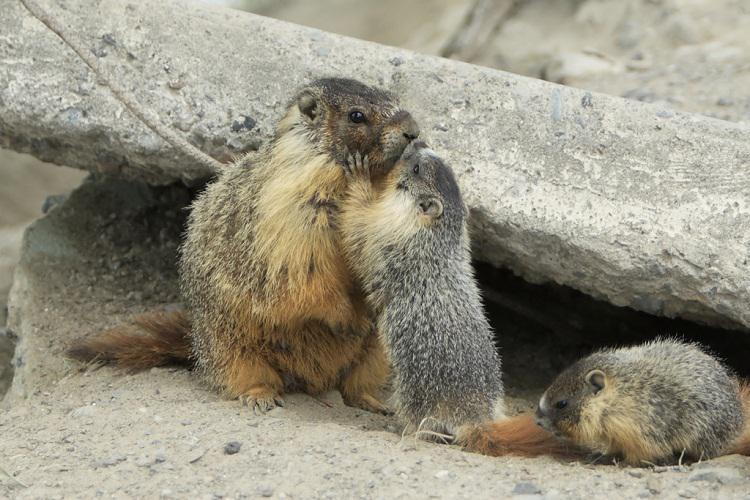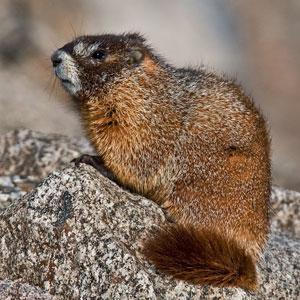The first image is the image on the left, the second image is the image on the right. Given the left and right images, does the statement "Each image shows just one groundhog-type animal, which is facing rightward." hold true? Answer yes or no. No. The first image is the image on the left, the second image is the image on the right. Examine the images to the left and right. Is the description "Both marmots are facing toward the right" accurate? Answer yes or no. No. 